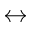Convert formula to latex. <formula><loc_0><loc_0><loc_500><loc_500>\leftrightarrow</formula> 